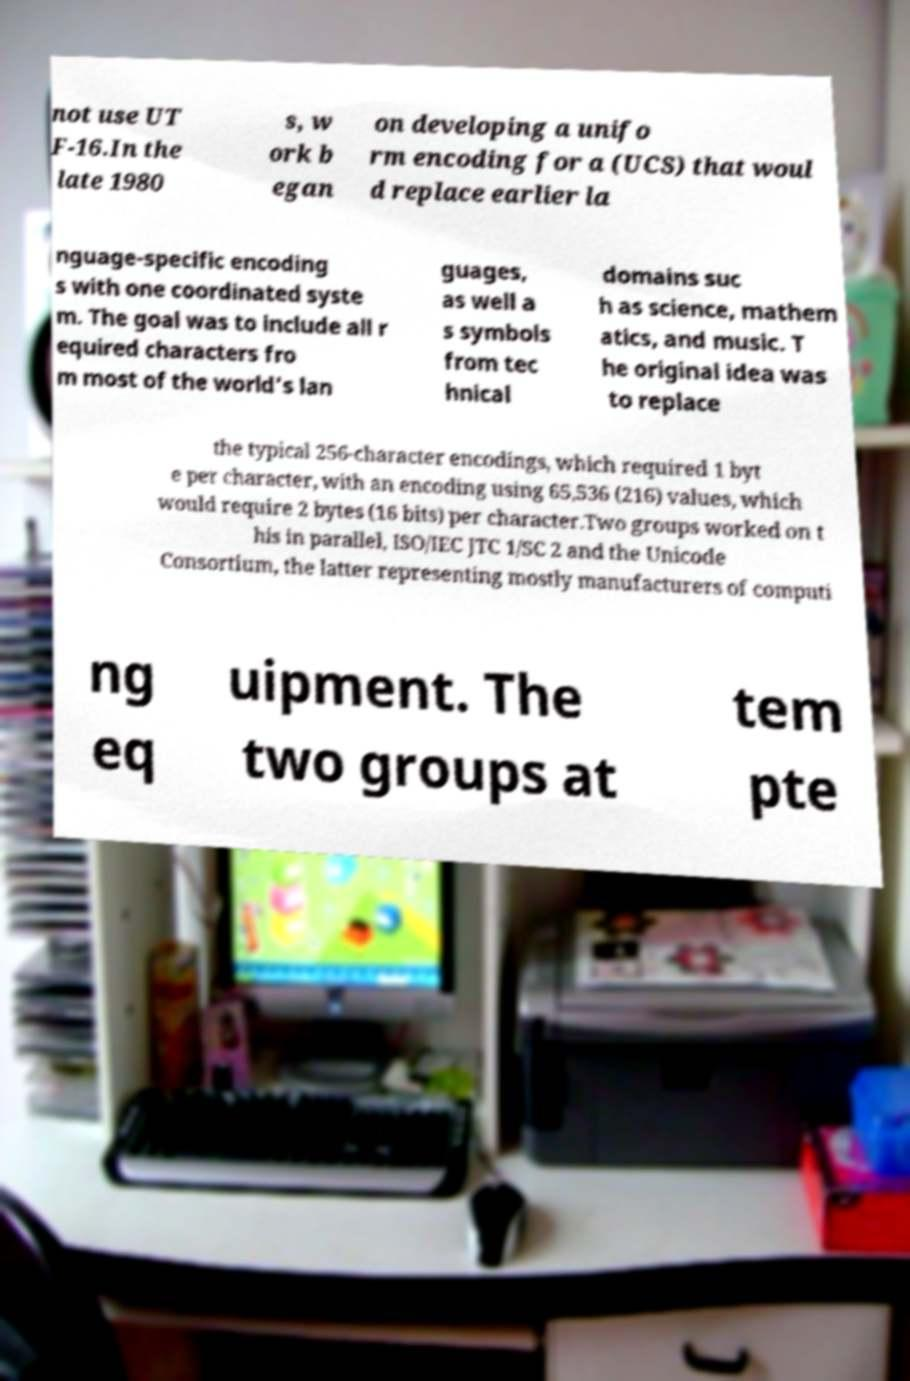Please read and relay the text visible in this image. What does it say? not use UT F-16.In the late 1980 s, w ork b egan on developing a unifo rm encoding for a (UCS) that woul d replace earlier la nguage-specific encoding s with one coordinated syste m. The goal was to include all r equired characters fro m most of the world's lan guages, as well a s symbols from tec hnical domains suc h as science, mathem atics, and music. T he original idea was to replace the typical 256-character encodings, which required 1 byt e per character, with an encoding using 65,536 (216) values, which would require 2 bytes (16 bits) per character.Two groups worked on t his in parallel, ISO/IEC JTC 1/SC 2 and the Unicode Consortium, the latter representing mostly manufacturers of computi ng eq uipment. The two groups at tem pte 